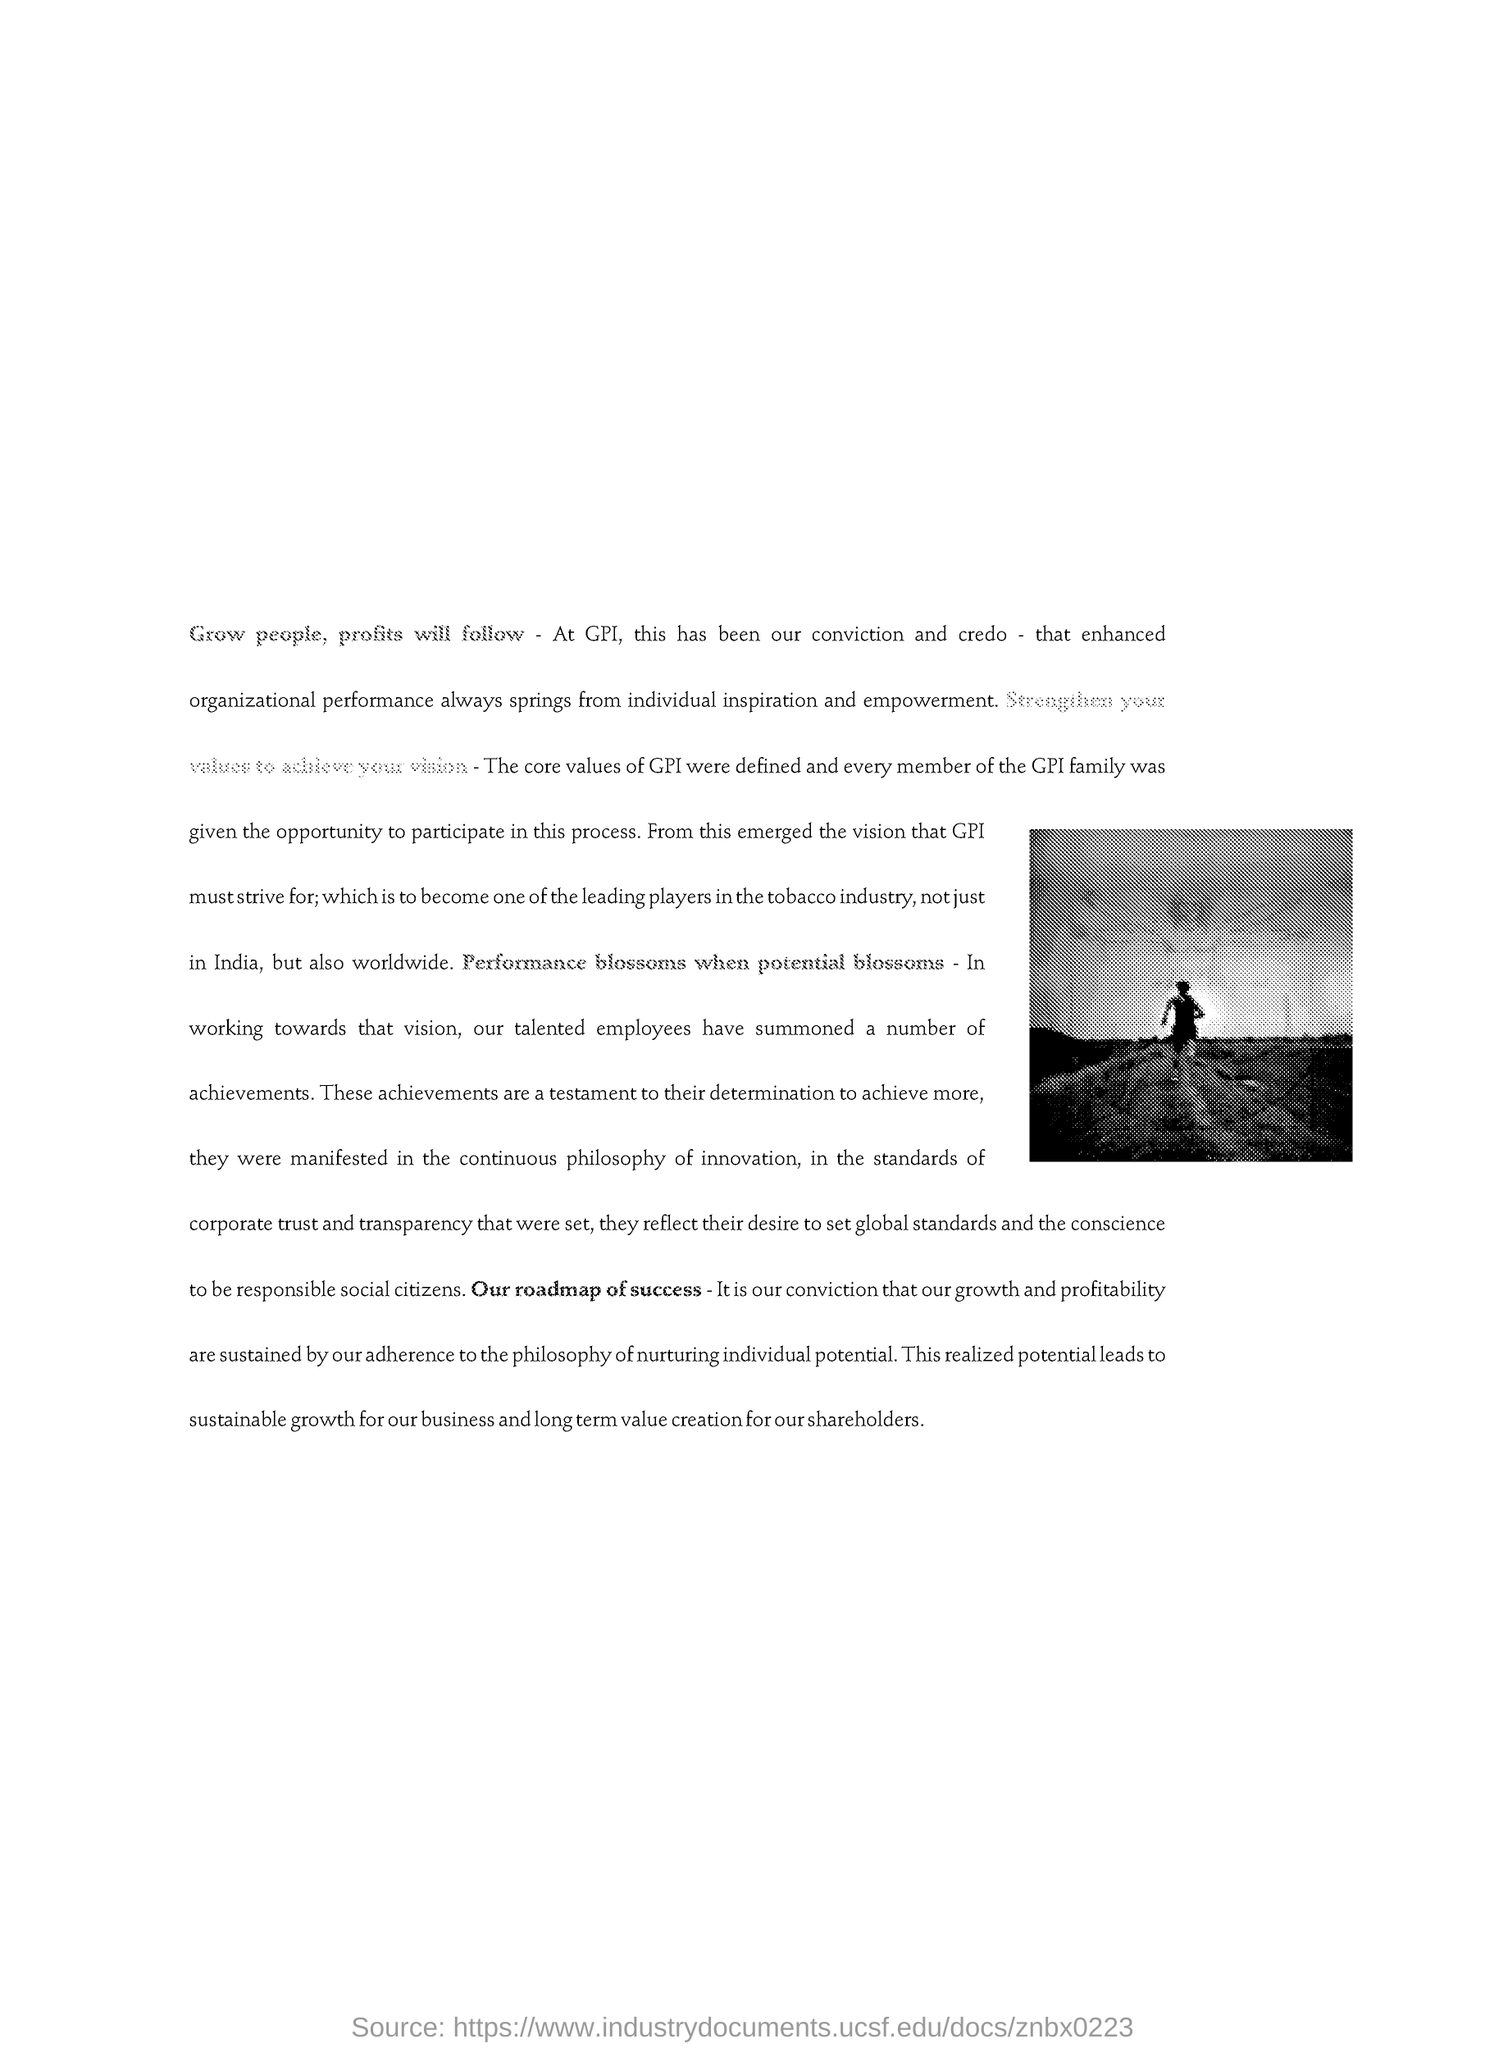Draw attention to some important aspects in this diagram. Our roadmap of success is clearly outlined and ready for implementation. 